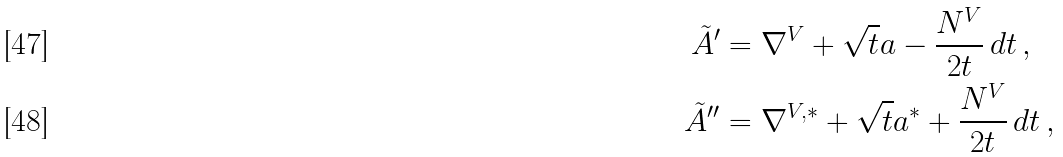Convert formula to latex. <formula><loc_0><loc_0><loc_500><loc_500>\tilde { A } ^ { \prime } & = \nabla ^ { V } + \sqrt { t } a - \frac { N ^ { V } } { 2 t } \, d t \, , \\ \tilde { A } ^ { \prime \prime } & = \nabla ^ { V , * } + \sqrt { t } a ^ { * } + \frac { N ^ { V } } { 2 t } \, d t \, ,</formula> 